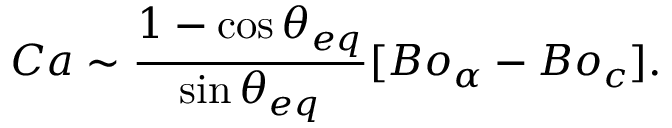Convert formula to latex. <formula><loc_0><loc_0><loc_500><loc_500>C a \sim \frac { 1 - \cos \theta _ { e q } } { \sin \theta _ { e q } } [ B o _ { \alpha } - B o _ { c } ] .</formula> 